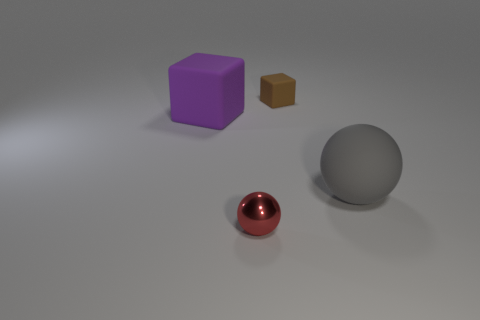Add 1 small gray matte balls. How many objects exist? 5 Add 1 big brown matte objects. How many big brown matte objects exist? 1 Subtract 0 green spheres. How many objects are left? 4 Subtract all big red spheres. Subtract all red balls. How many objects are left? 3 Add 1 tiny red things. How many tiny red things are left? 2 